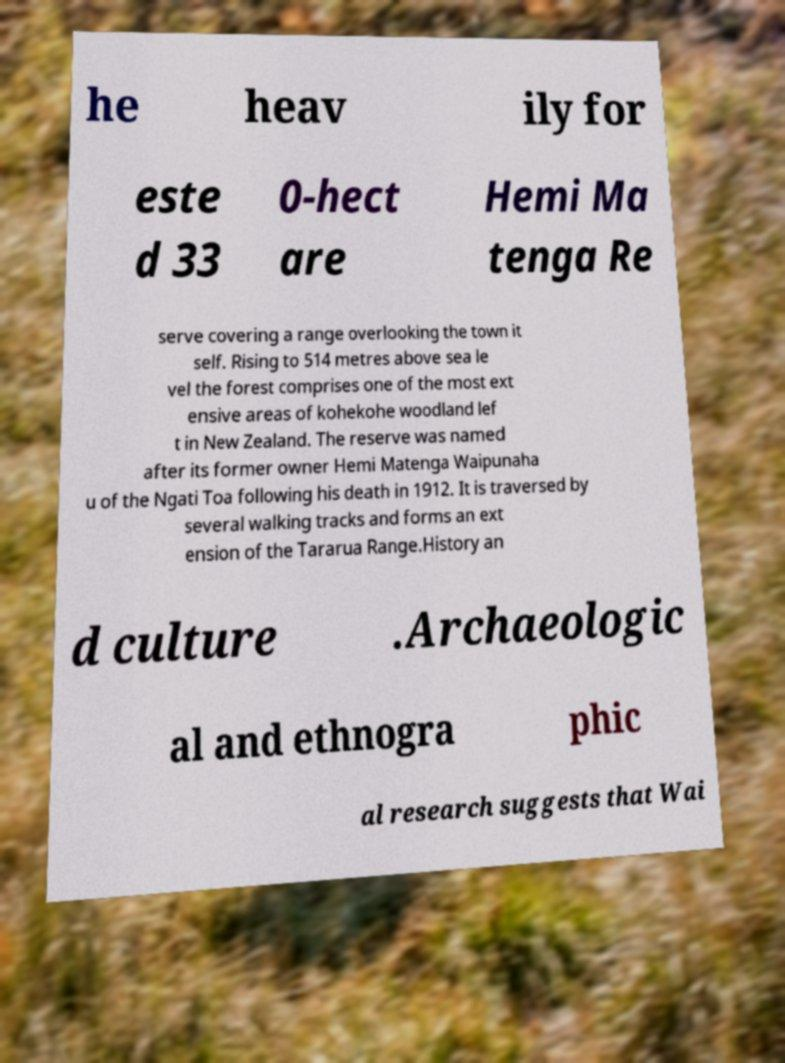Please identify and transcribe the text found in this image. he heav ily for este d 33 0-hect are Hemi Ma tenga Re serve covering a range overlooking the town it self. Rising to 514 metres above sea le vel the forest comprises one of the most ext ensive areas of kohekohe woodland lef t in New Zealand. The reserve was named after its former owner Hemi Matenga Waipunaha u of the Ngati Toa following his death in 1912. It is traversed by several walking tracks and forms an ext ension of the Tararua Range.History an d culture .Archaeologic al and ethnogra phic al research suggests that Wai 